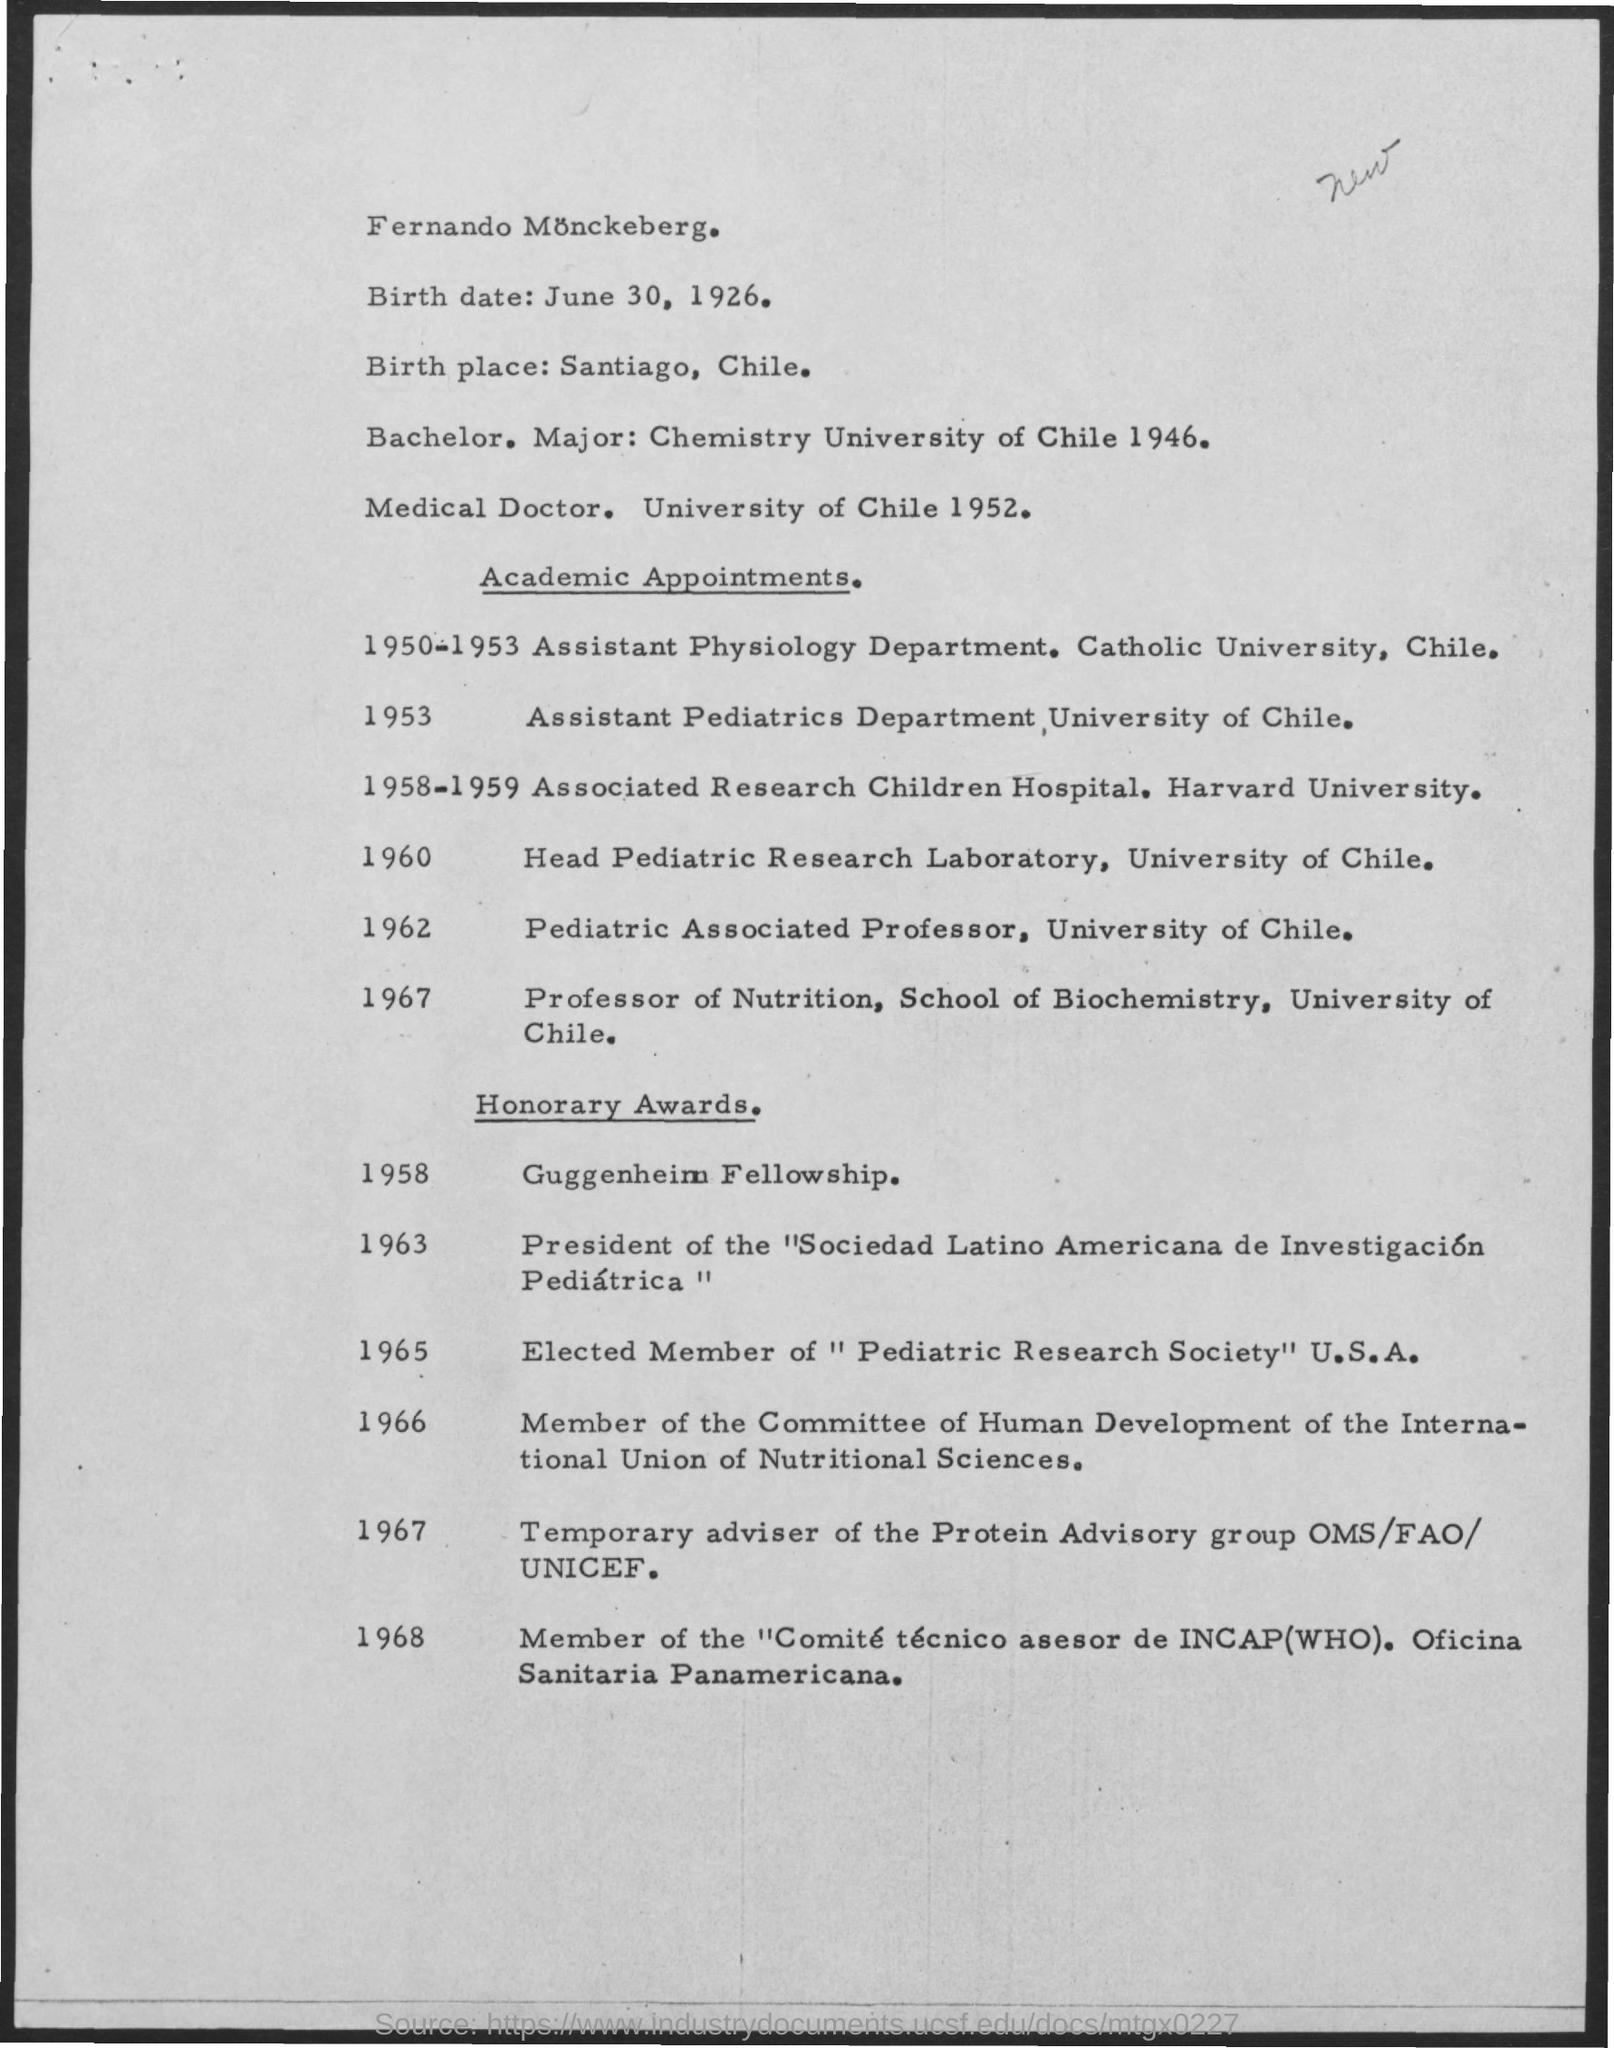What is the birth date ?
Your answer should be very brief. JUNE 30, 1926. Guggenheim fellowship was awarded in which year ?
Provide a short and direct response. 1958. In which year assistant pediatrics department , university of chile had an academic  appointment
Your answer should be very brief. 1953. "In which year they were awarded as elected member of "pediatric research society " U.S.A
Provide a short and direct response. 1965. 